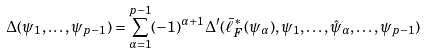<formula> <loc_0><loc_0><loc_500><loc_500>\Delta ( \psi _ { 1 } , \dots , \psi _ { p - 1 } ) = \sum _ { \alpha = 1 } ^ { p - 1 } ( - 1 ) ^ { \alpha + 1 } \Delta ^ { \prime } ( \bar { \ell } _ { F } ^ { * } ( \psi _ { \alpha } ) , \psi _ { 1 } , \dots , \hat { \psi } _ { \alpha } , \dots , \psi _ { p - 1 } )</formula> 